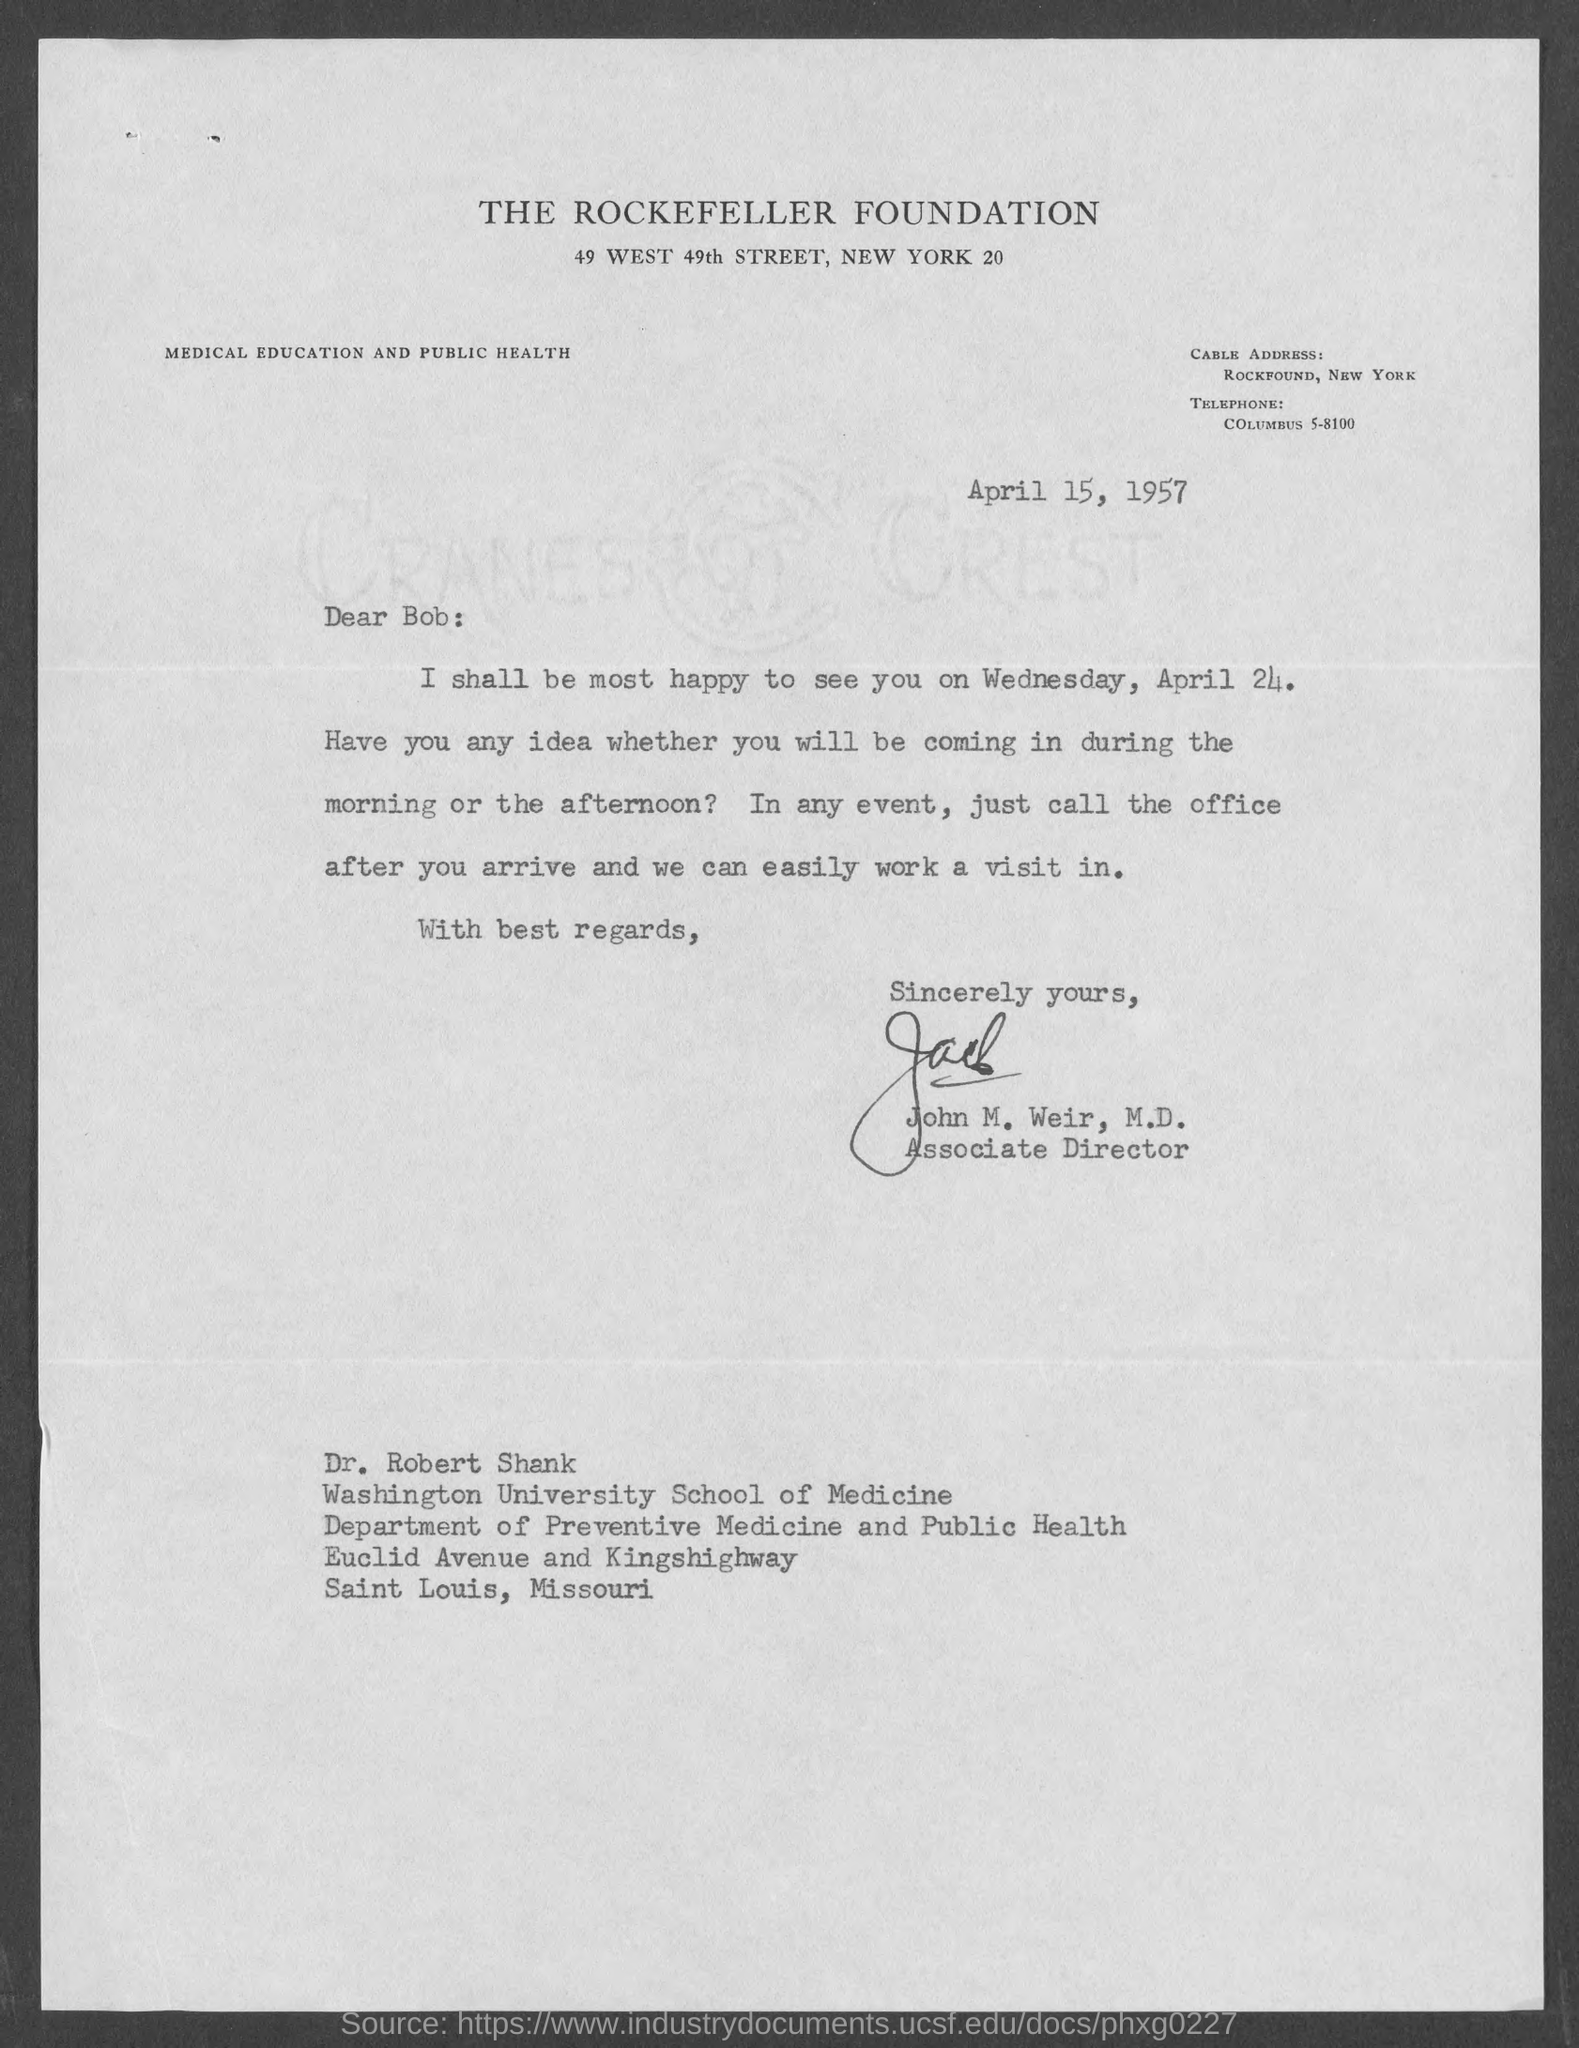Point out several critical features in this image. The cable address provided in the letter is "ROCKFOUND, NEW YORK. The Rockefeller Foundation is the organization mentioned on the letterhead. The issued date of the letter is April 15, 1957. The letter's sender is John M. Weir. John M. Weir, M.D. holds the designation of Associate Director. 